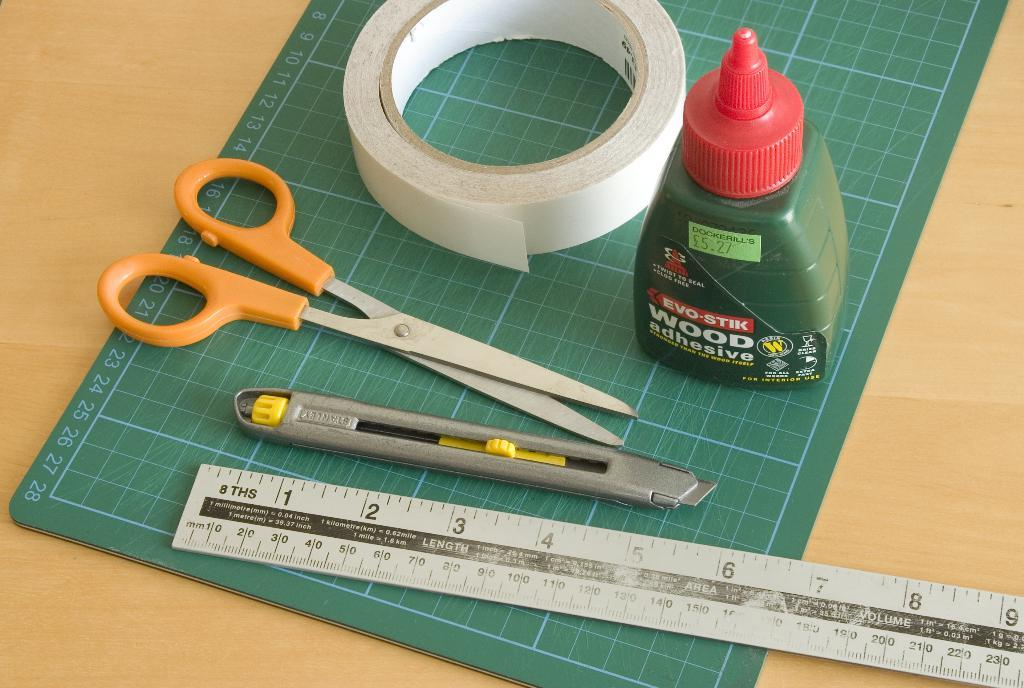Provide a one-sentence caption for the provided image. measuring tools and implements including EVO-STICK Wood Adhesive. 